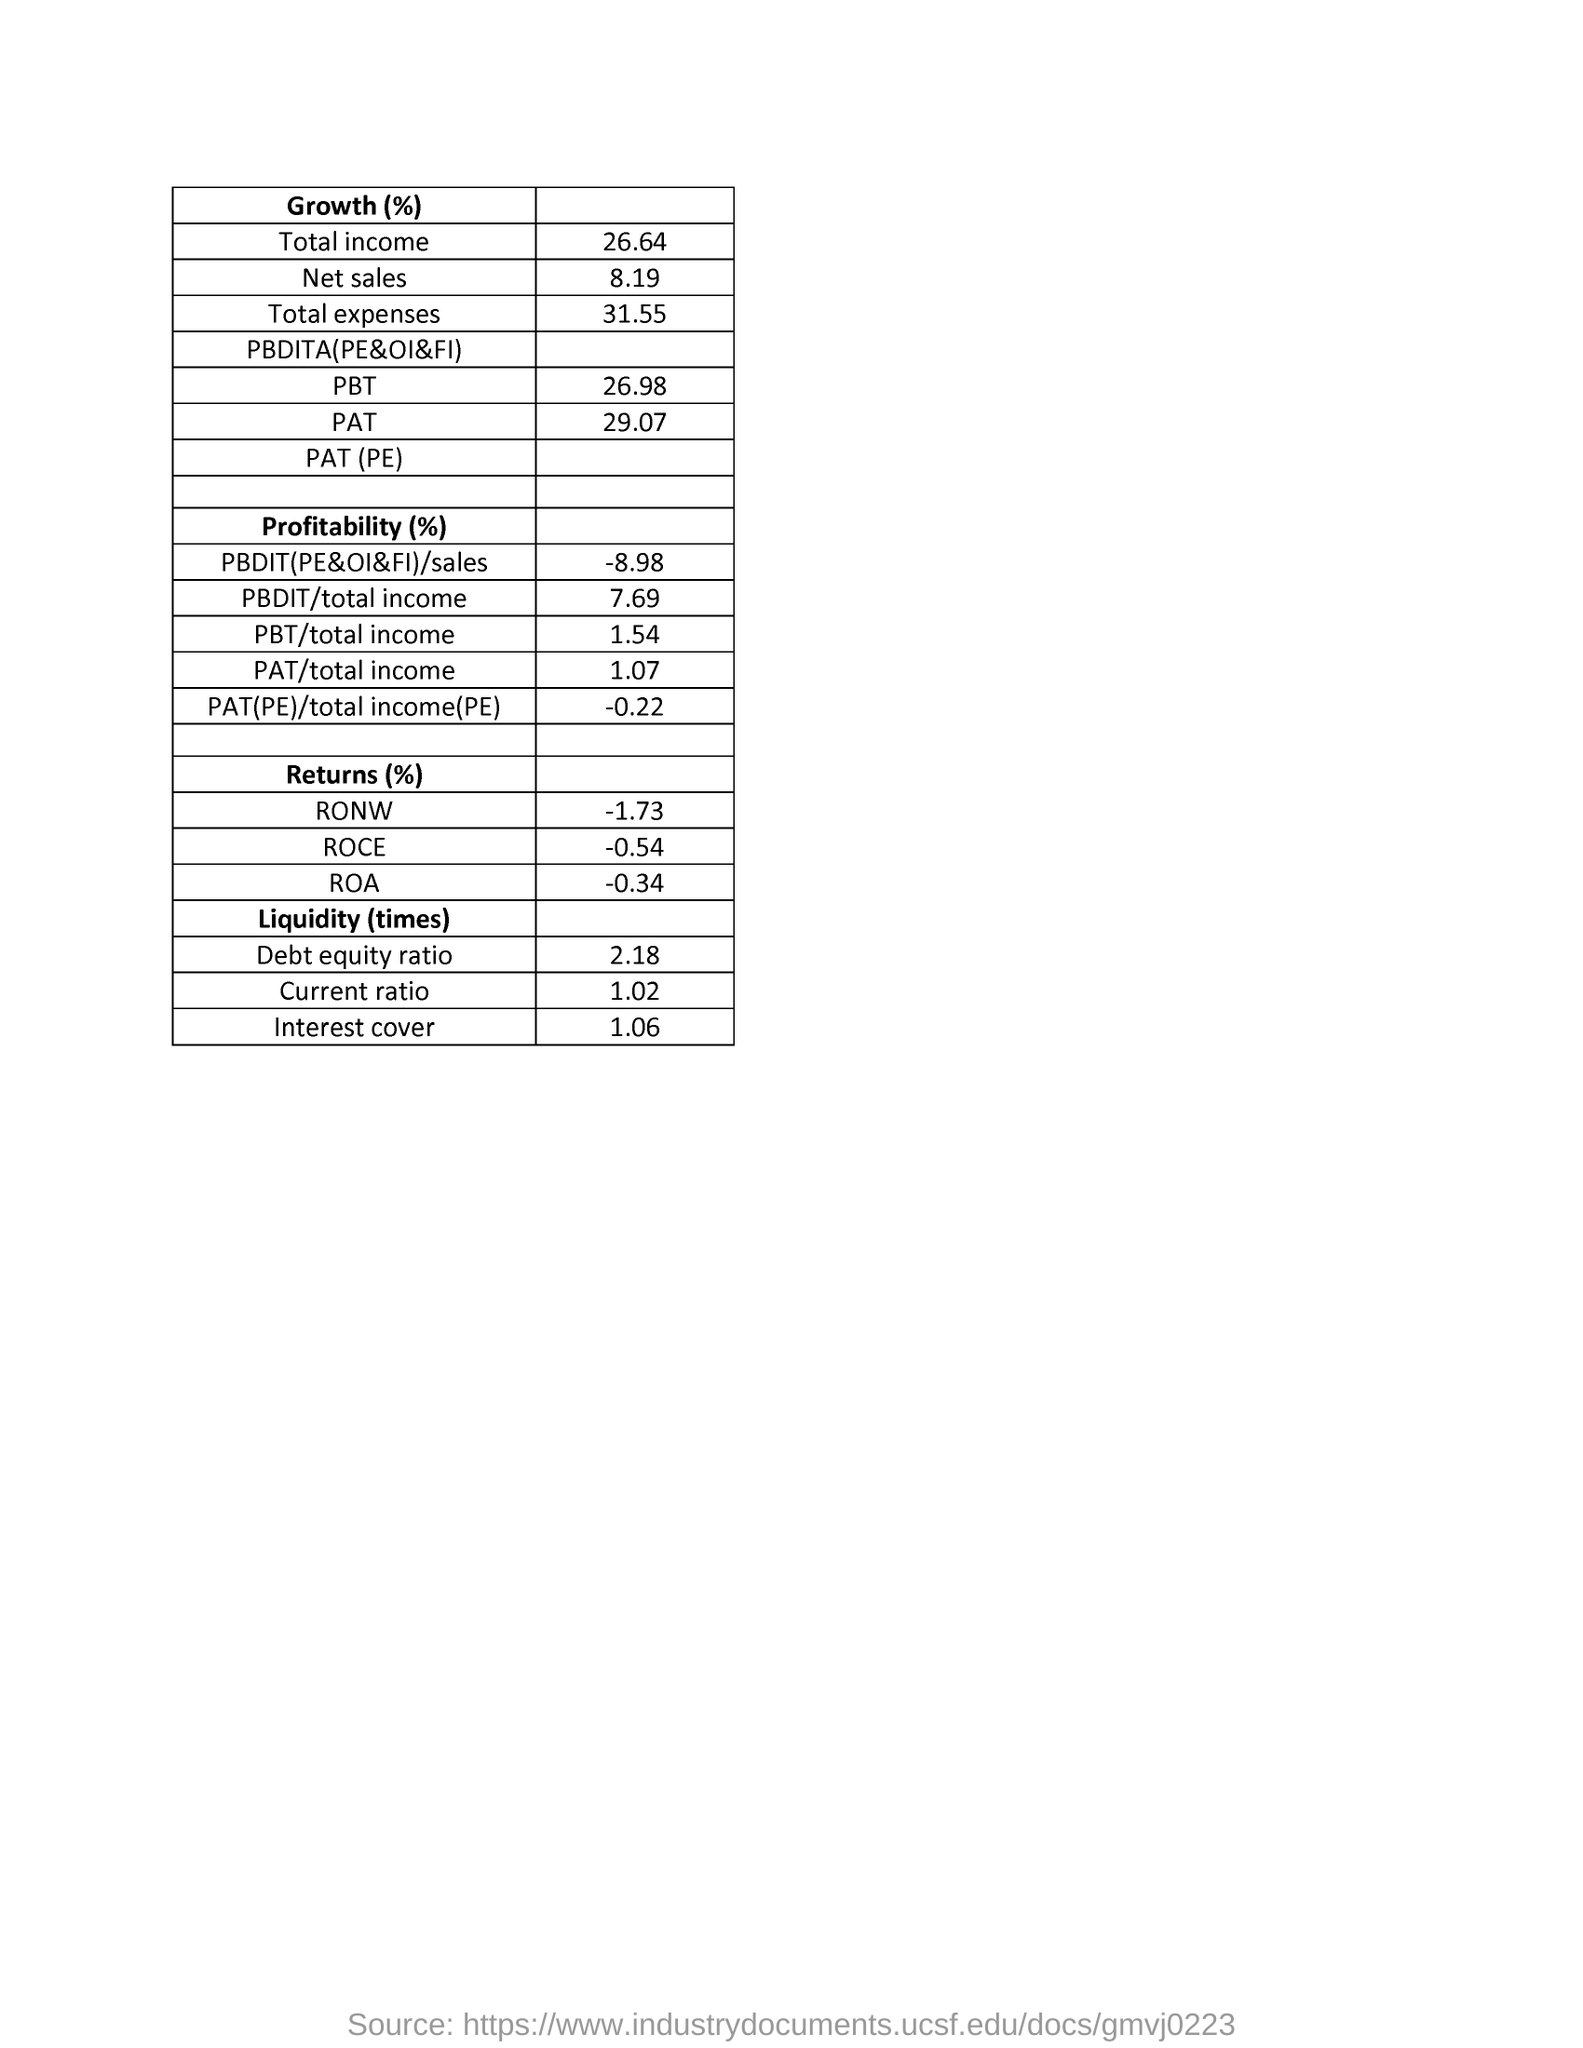Draw attention to some important aspects in this diagram. The debt-to-equity ratio mentioned in the document is 2.18. The total income mentioned in the document is 26.64. The total expenses mentioned in the document are 31.55%. 